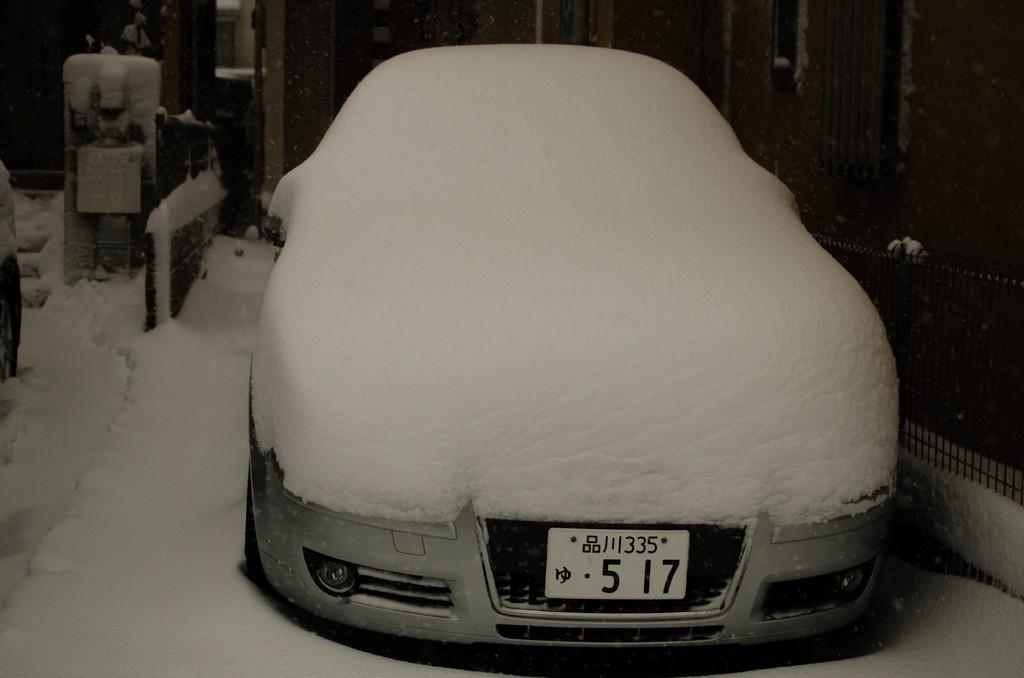Provide a one-sentence caption for the provided image. Snow covers a silver car with the license plate 5 17. 